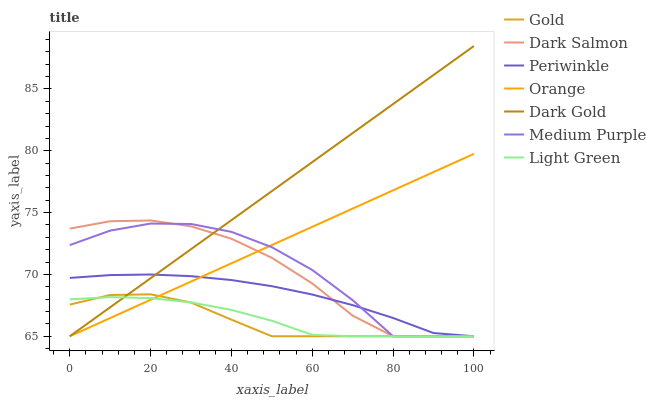Does Dark Salmon have the minimum area under the curve?
Answer yes or no. No. Does Dark Salmon have the maximum area under the curve?
Answer yes or no. No. Is Dark Gold the smoothest?
Answer yes or no. No. Is Dark Gold the roughest?
Answer yes or no. No. Does Dark Salmon have the highest value?
Answer yes or no. No. 